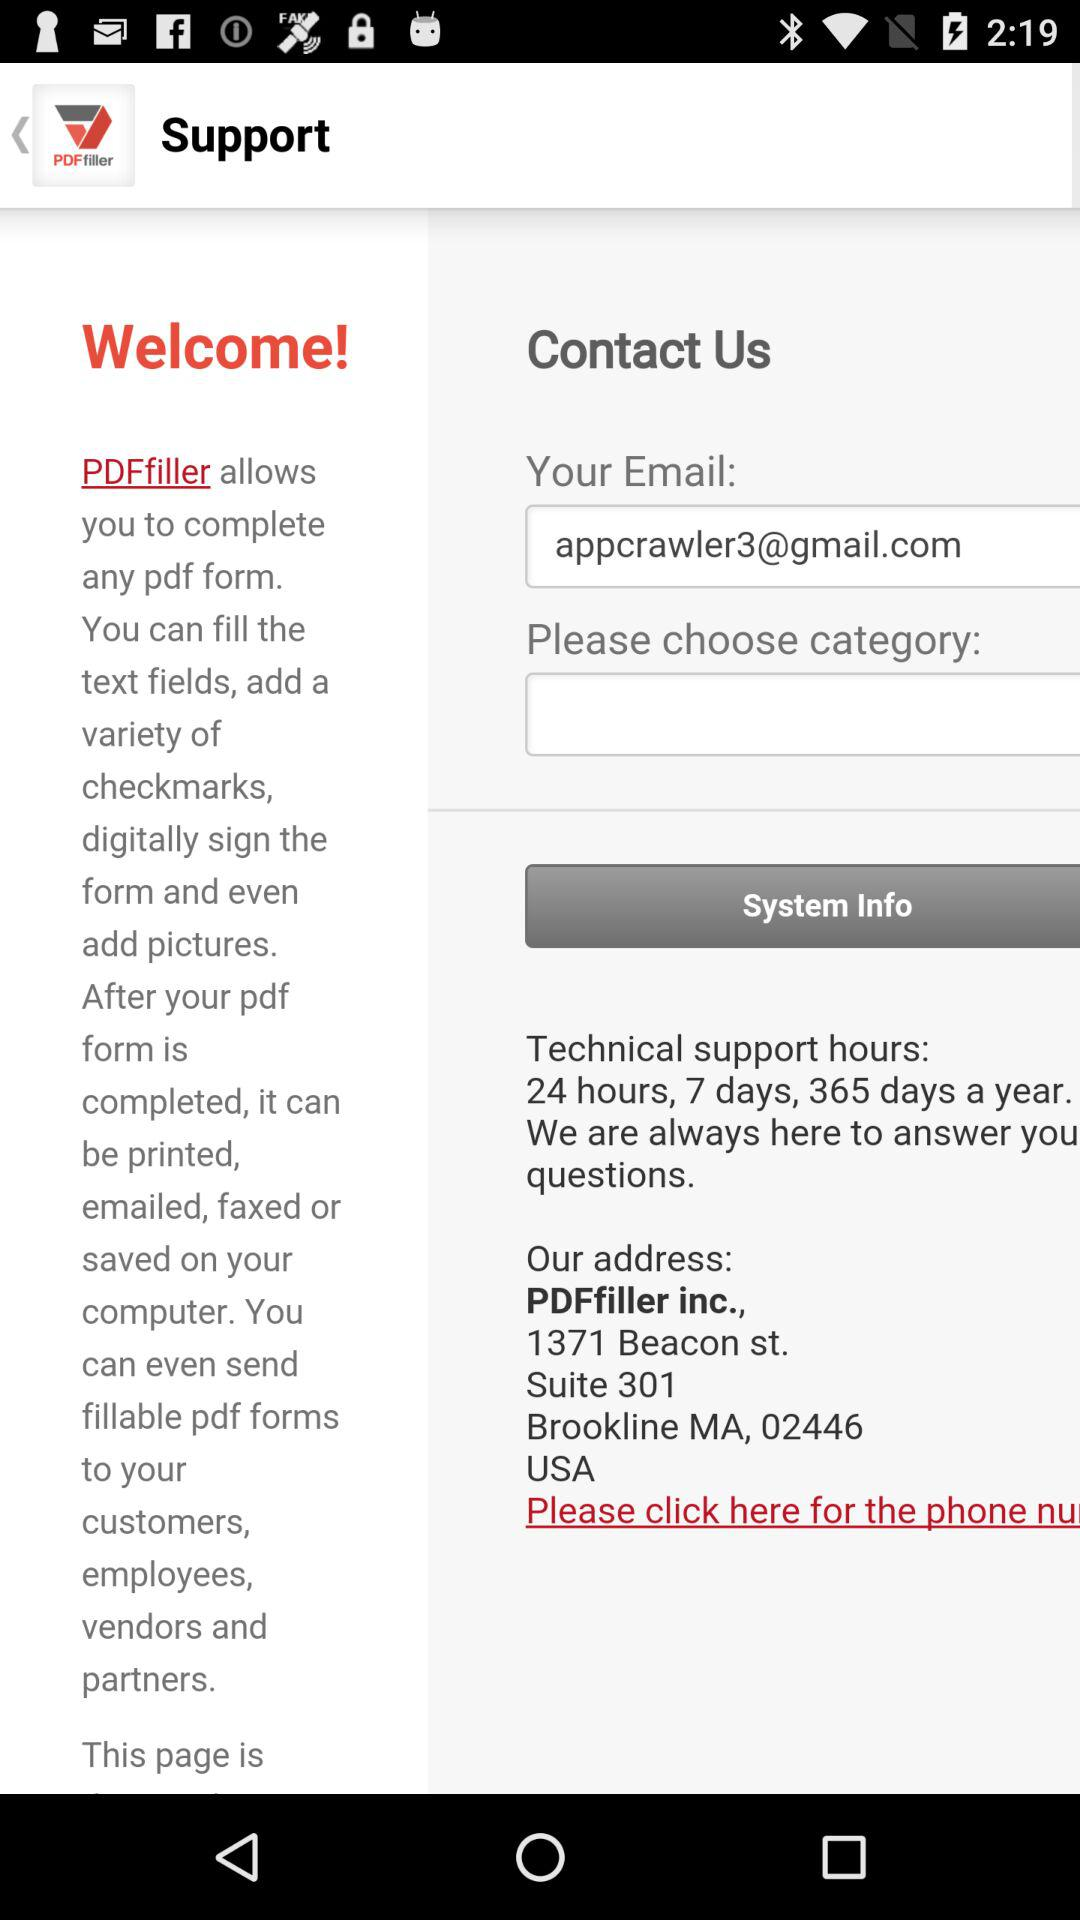What is the email address? The email address is appcrawler3@gmail.com. 